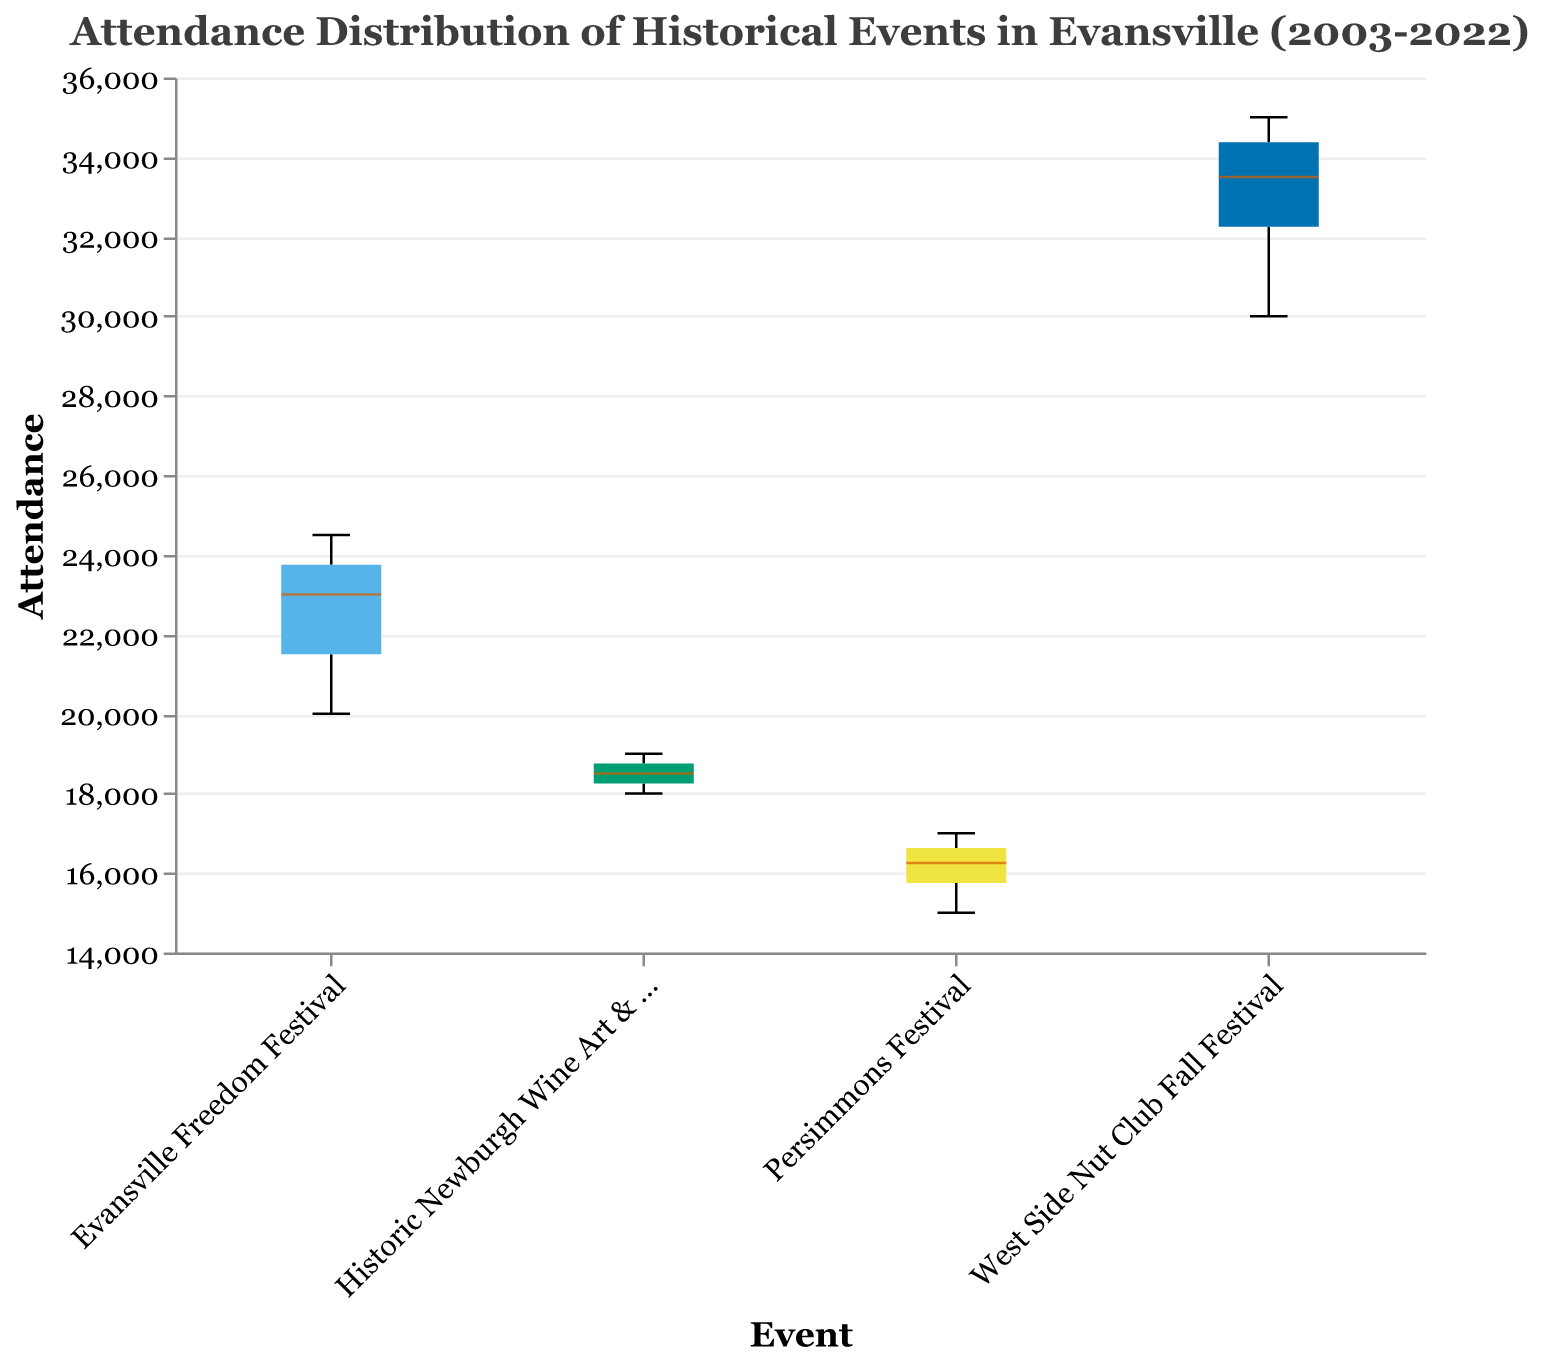What is the title of the figure? The title is displayed at the top of the figure and provides a summary of the content.
Answer: Attendance Distribution of Historical Events in Evansville (2003-2022) Which event has the highest median attendance? Look at the middle line in the box for each event, which indicates the median.
Answer: West Side Nut Club Fall Festival What is the median attendance for the Evansville Freedom Festival? Identify the middle line in the box for the Evansville Freedom Festival.
Answer: 23500 Which event has the smallest range of attendance values? Observe the length of the box and whiskers for each event, the smallest range will have the shortest box-and-whisker length.
Answer: Persimmons Festival Compare the maximum attendance of the West Side Nut Club Fall Festival and the Evansville Freedom Festival. Look at the highest points (top whiskers) for both events.
Answer: West Side Nut Club Fall Festival has a higher maximum attendance What is the interquartile range (IQR) for the Historic Newburgh Wine Art & Jazz Festival? The IQR is the height of the box. Measure the distance between the top and bottom of the box representing the 75th and 25th percentiles.
Answer: 19000 - 18000 = 1000 Which event shows the most consistent attendance over the years? Look for the box with the least variance, meaning a smaller box and whiskers.
Answer: Persimmons Festival How does the average attendance of the Persimmons Festival compare with that of the Historic Newburgh Wine Art & Jazz Festival? Calculate the average attendance for both events (sum of attendance values divided by number of years) and compare.
Answer: The Persimmons Festival has a slightly lower average attendance Which events had outliers in their attendance data? Identify any points outside the whiskers of the box plots.
Answer: No events show outliers What is the difference between the highest and lowest attendance points for the West Side Nut Club Fall Festival? Subtract the lowest attendance value from the highest attendance value for this event.
Answer: 35000 - 30000 = 5000 